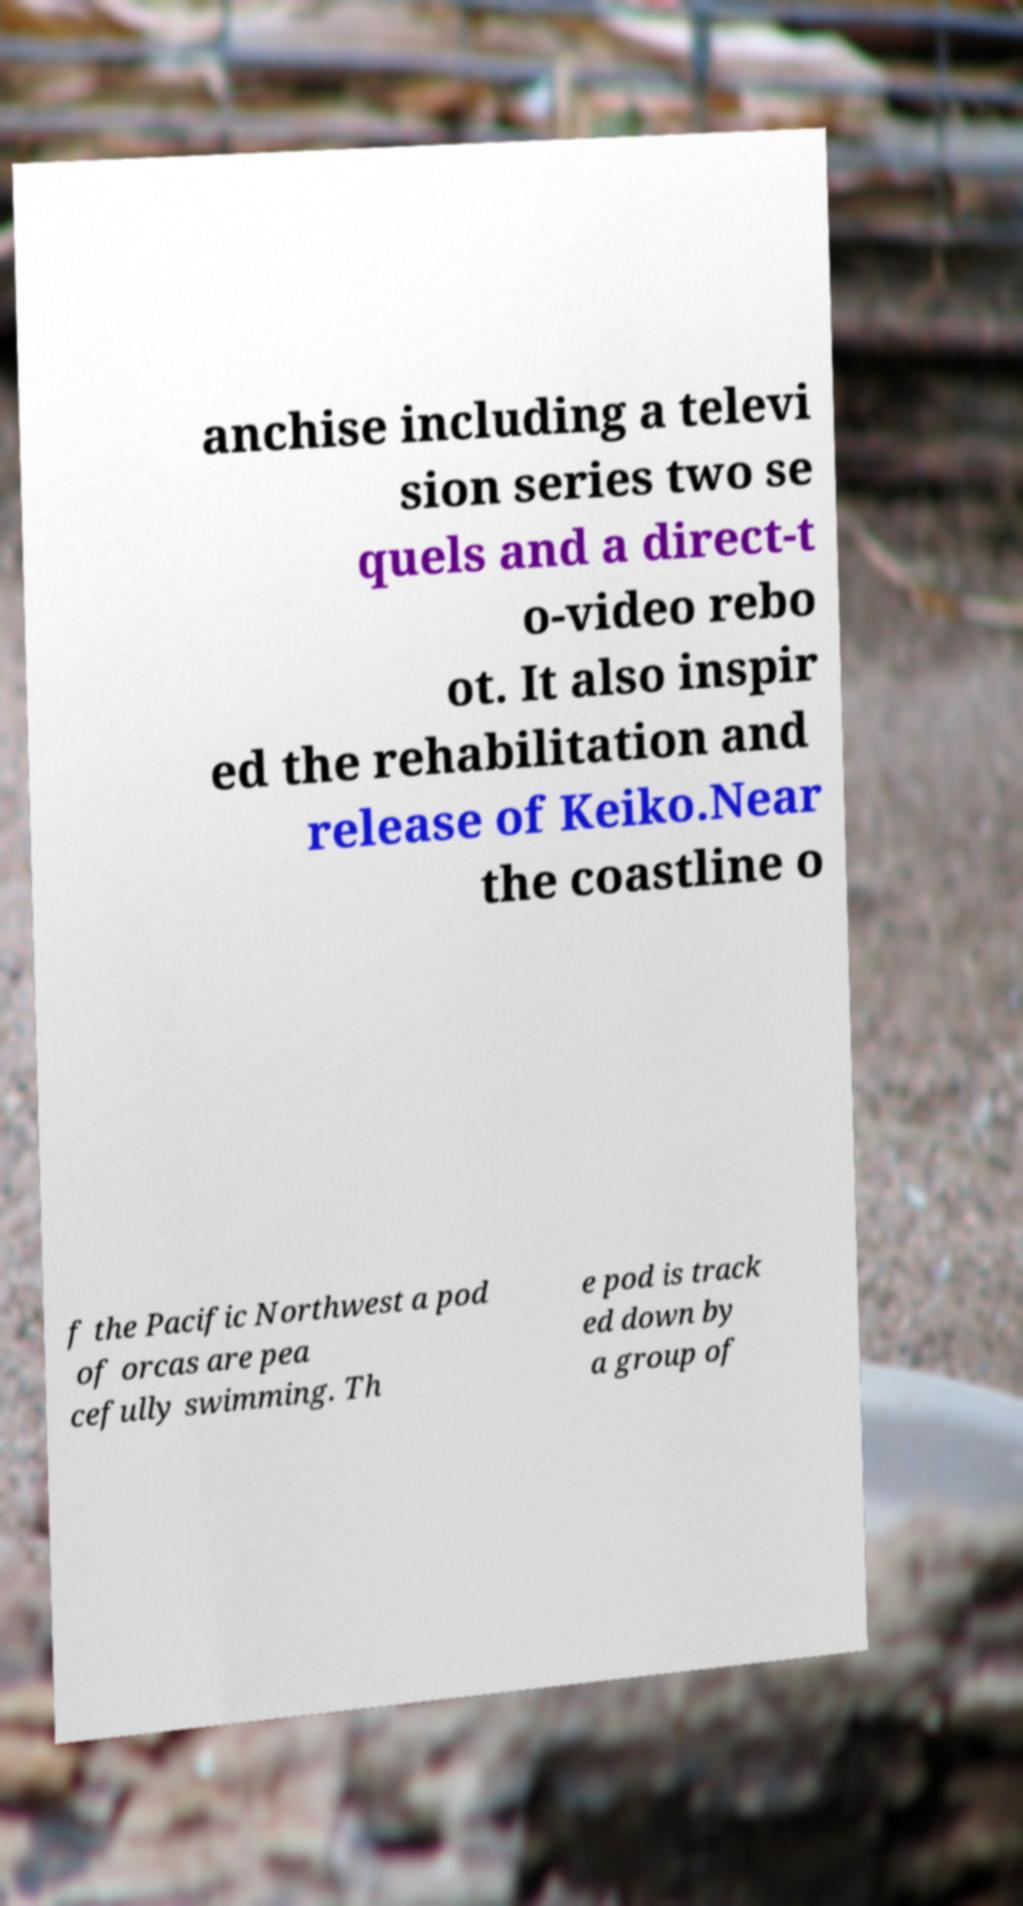Please identify and transcribe the text found in this image. anchise including a televi sion series two se quels and a direct-t o-video rebo ot. It also inspir ed the rehabilitation and release of Keiko.Near the coastline o f the Pacific Northwest a pod of orcas are pea cefully swimming. Th e pod is track ed down by a group of 